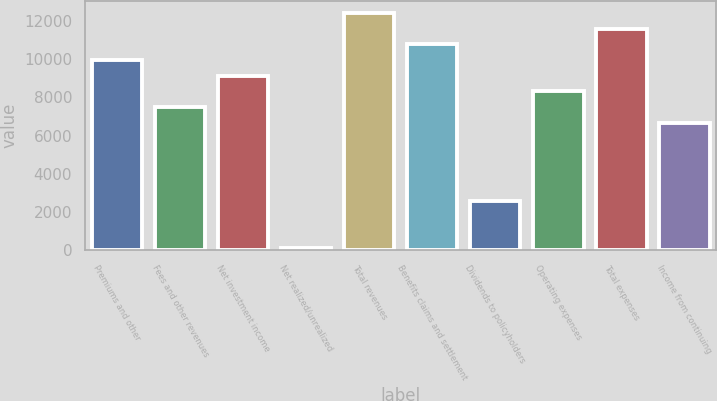Convert chart to OTSL. <chart><loc_0><loc_0><loc_500><loc_500><bar_chart><fcel>Premiums and other<fcel>Fees and other revenues<fcel>Net investment income<fcel>Net realized/unrealized<fcel>Total revenues<fcel>Benefits claims and settlement<fcel>Dividends to policyholders<fcel>Operating expenses<fcel>Total expenses<fcel>Income from continuing<nl><fcel>9964.12<fcel>7499.29<fcel>9142.51<fcel>104.8<fcel>12429<fcel>10785.7<fcel>2569.63<fcel>8320.9<fcel>11607.3<fcel>6677.68<nl></chart> 